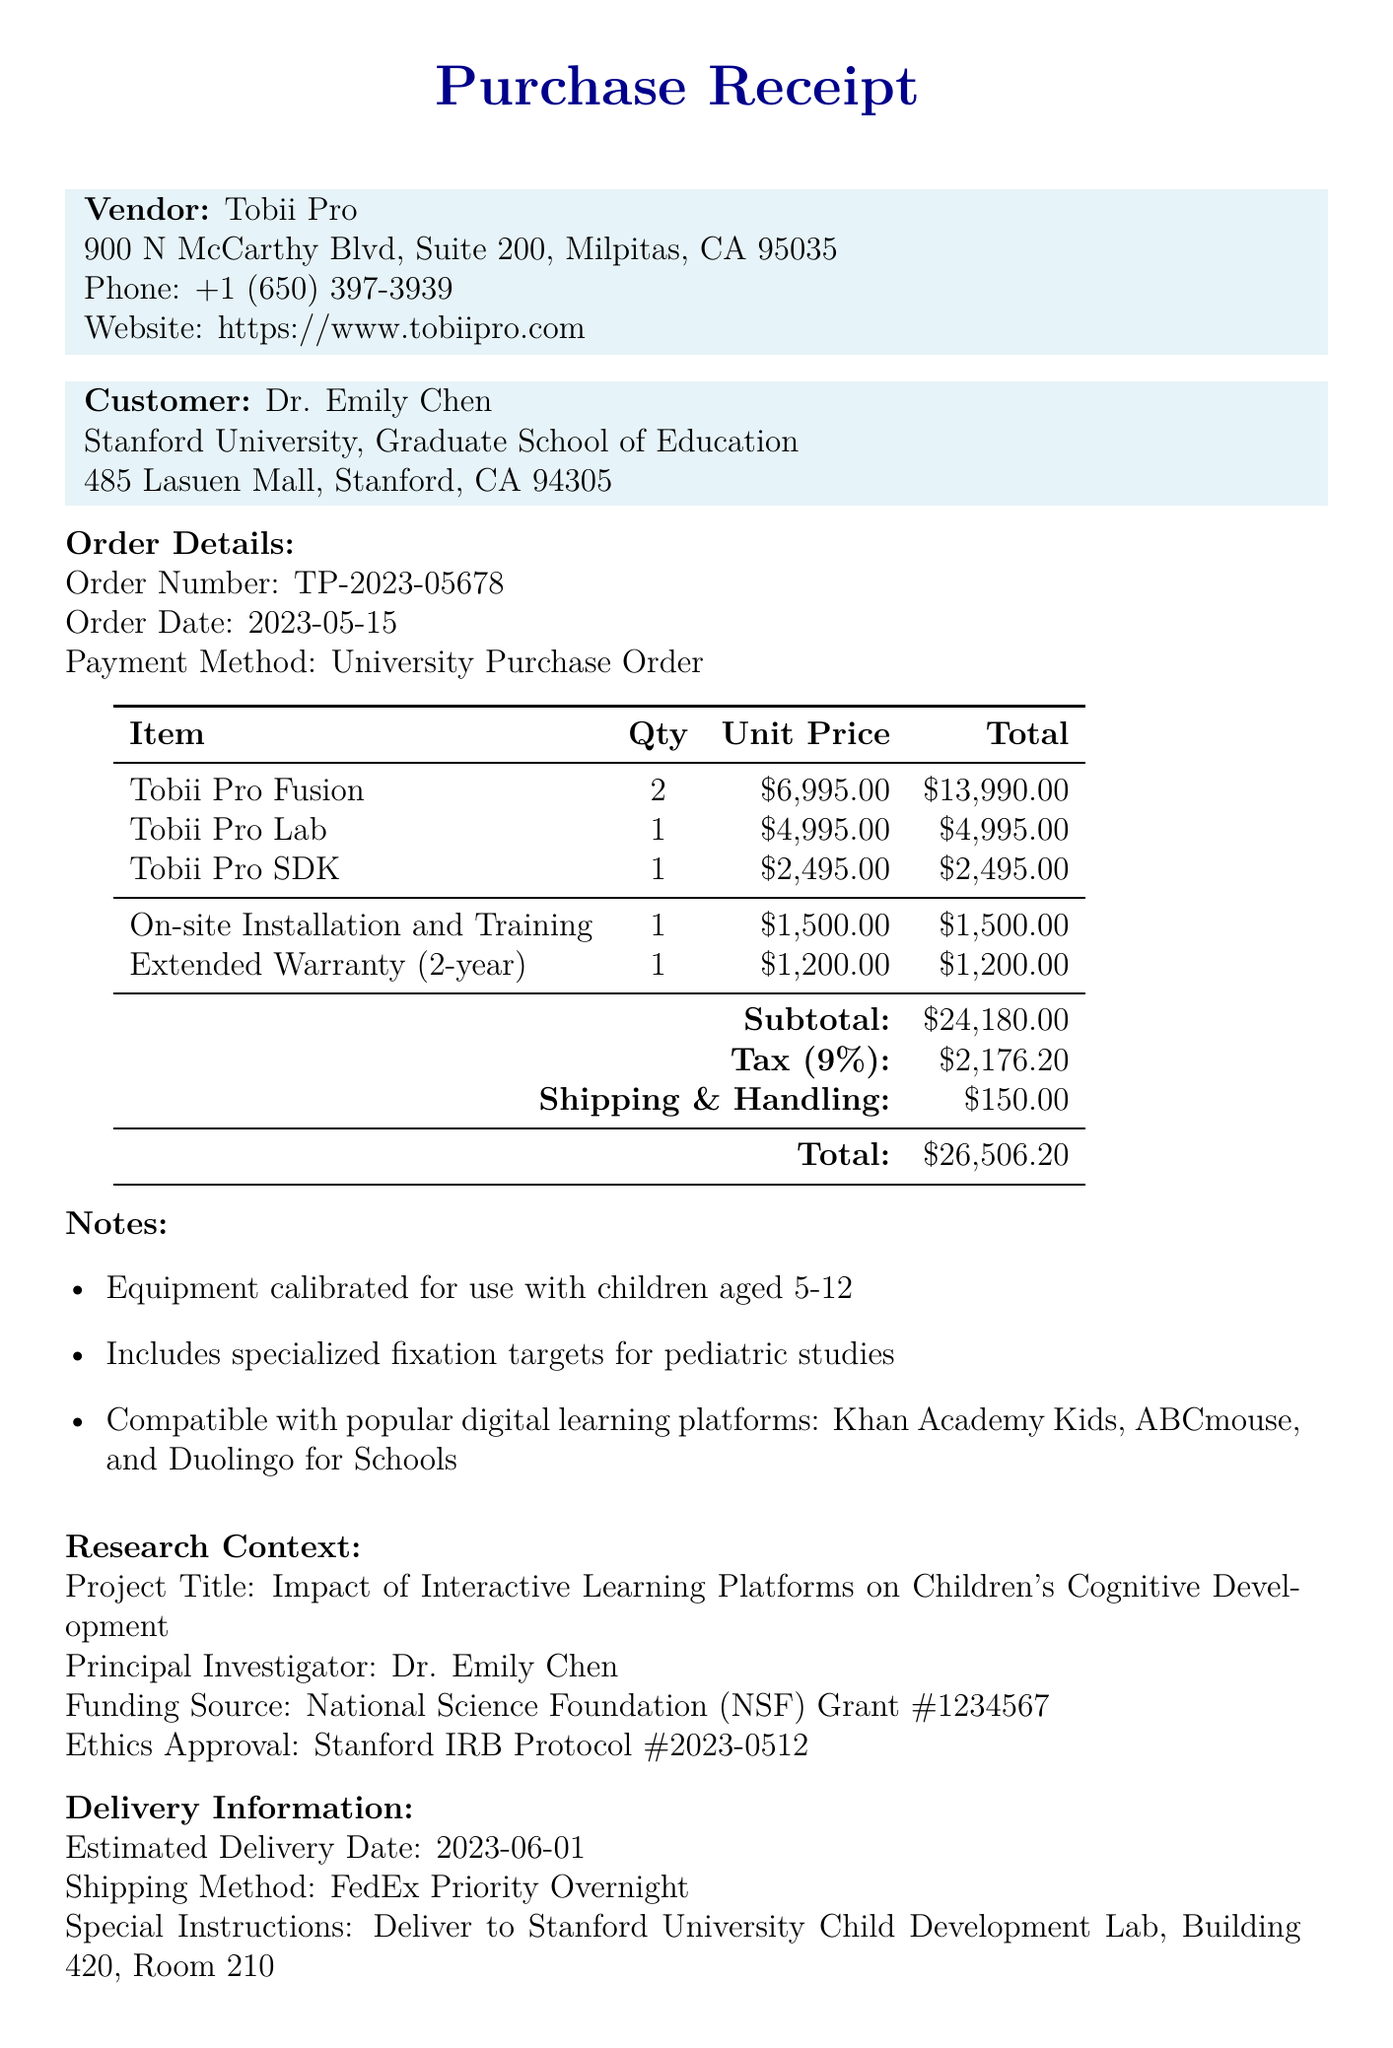What is the name of the vendor? The vendor is identified at the beginning of the receipt, specifically as Tobii Pro.
Answer: Tobii Pro What is the order number? The order number is stated clearly in the order details section of the document.
Answer: TP-2023-05678 What is the total amount of the purchase? The total amount can be found at the end of the financial section of the receipt, which includes all items, taxes, and shipping.
Answer: 26,506.20 How many Tobii Pro Fusion units were purchased? The quantity of Tobii Pro Fusion units is specified in the items list.
Answer: 2 What is the estimated delivery date? The estimated delivery date is provided in the delivery information section of the document.
Answer: 2023-06-01 Who is the principal investigator of the research project? The principal investigator is mentioned in the research context section of the document.
Answer: Dr. Emily Chen What software is included for eye tracking data collection and analysis? The software intended for eye tracking data collection is listed in the items section of the receipt.
Answer: Tobii Pro Lab What additional service costs $1500.00? The receipt lists all additional services, and the one costing $1500.00 is specified explicitly.
Answer: On-site Installation and Training Which organizations are compatible with the equipment? The note section lists organizations compatible with the equipment, highlighting those specific to educational platforms.
Answer: Khan Academy Kids, ABCmouse, Duolingo for Schools 